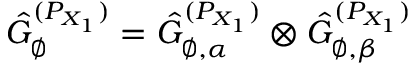Convert formula to latex. <formula><loc_0><loc_0><loc_500><loc_500>\hat { G } _ { \varnothing } ^ { ( P _ { X _ { 1 } } ) } = \hat { G } _ { \varnothing , \alpha } ^ { ( P _ { X _ { 1 } } ) } \otimes \hat { G } _ { \varnothing , \beta } ^ { ( P _ { X _ { 1 } } ) }</formula> 